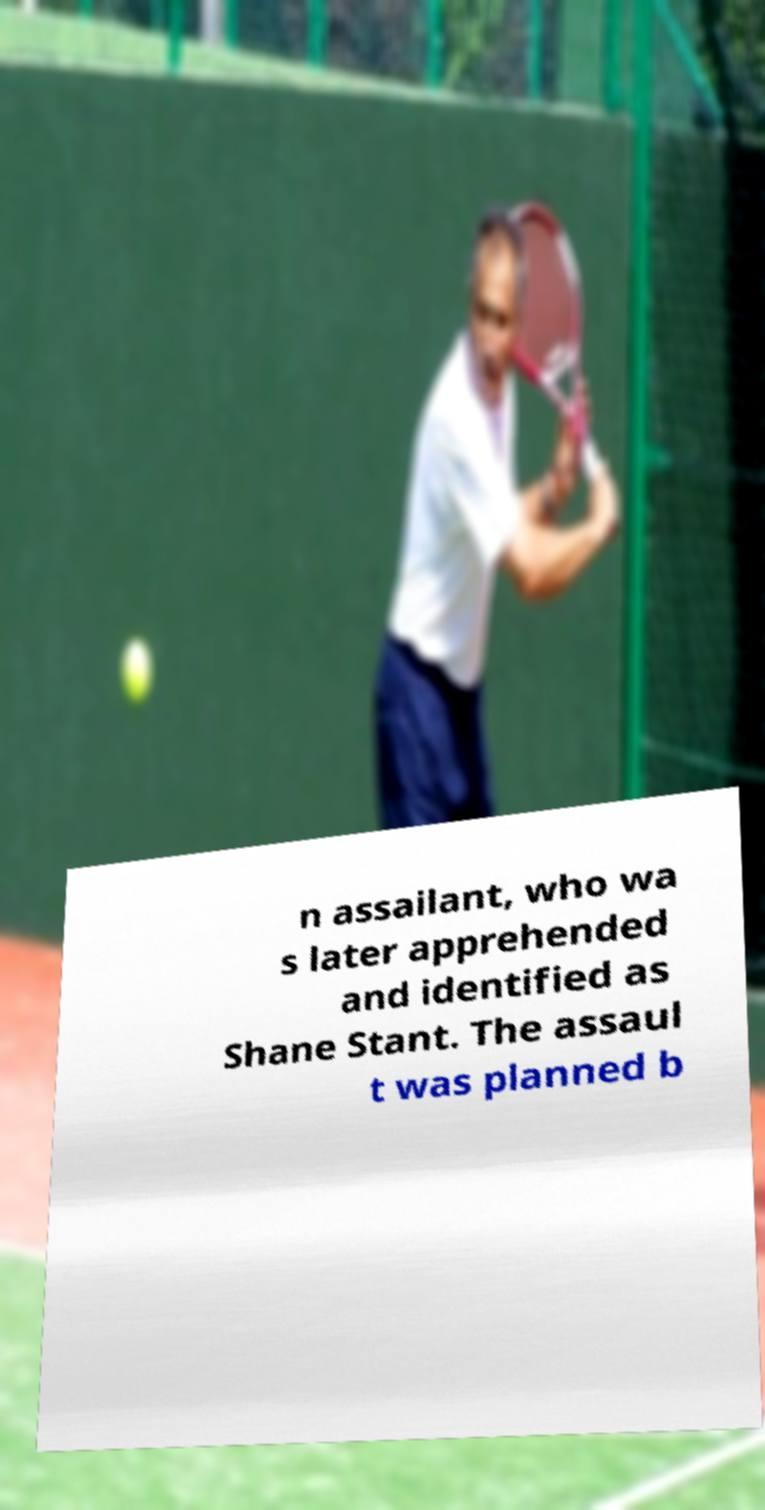Please identify and transcribe the text found in this image. n assailant, who wa s later apprehended and identified as Shane Stant. The assaul t was planned b 